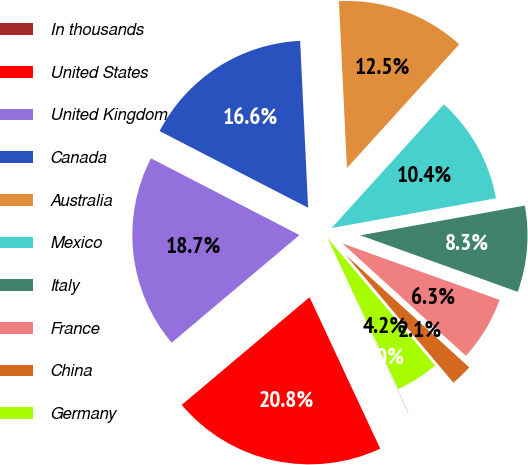Convert chart to OTSL. <chart><loc_0><loc_0><loc_500><loc_500><pie_chart><fcel>In thousands<fcel>United States<fcel>United Kingdom<fcel>Canada<fcel>Australia<fcel>Mexico<fcel>Italy<fcel>France<fcel>China<fcel>Germany<nl><fcel>0.02%<fcel>20.81%<fcel>18.73%<fcel>16.65%<fcel>12.49%<fcel>10.42%<fcel>8.34%<fcel>6.26%<fcel>2.1%<fcel>4.18%<nl></chart> 